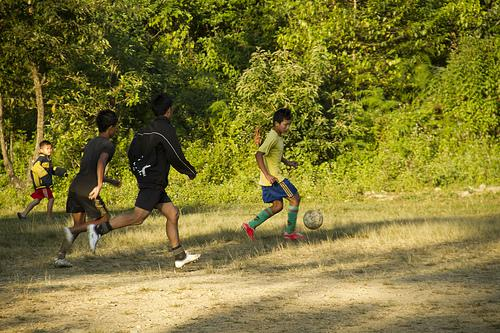Question: where was the photo taken?
Choices:
A. Zoo.
B. At the park.
C. Las Vegas.
D. In the mountains.
Answer with the letter. Answer: B Question: what is green?
Choices:
A. The leaves.
B. The grass.
C. The shirt.
D. The trees.
Answer with the letter. Answer: D Question: what are the boys playing?
Choices:
A. Basketball.
B. Baseball.
C. Football.
D. Soccer.
Answer with the letter. Answer: D Question: why is it so bright?
Choices:
A. Sunny.
B. All of the lights are on.
C. There's a flashlight on.
D. The phone screen is illuminating the room.
Answer with the letter. Answer: A 